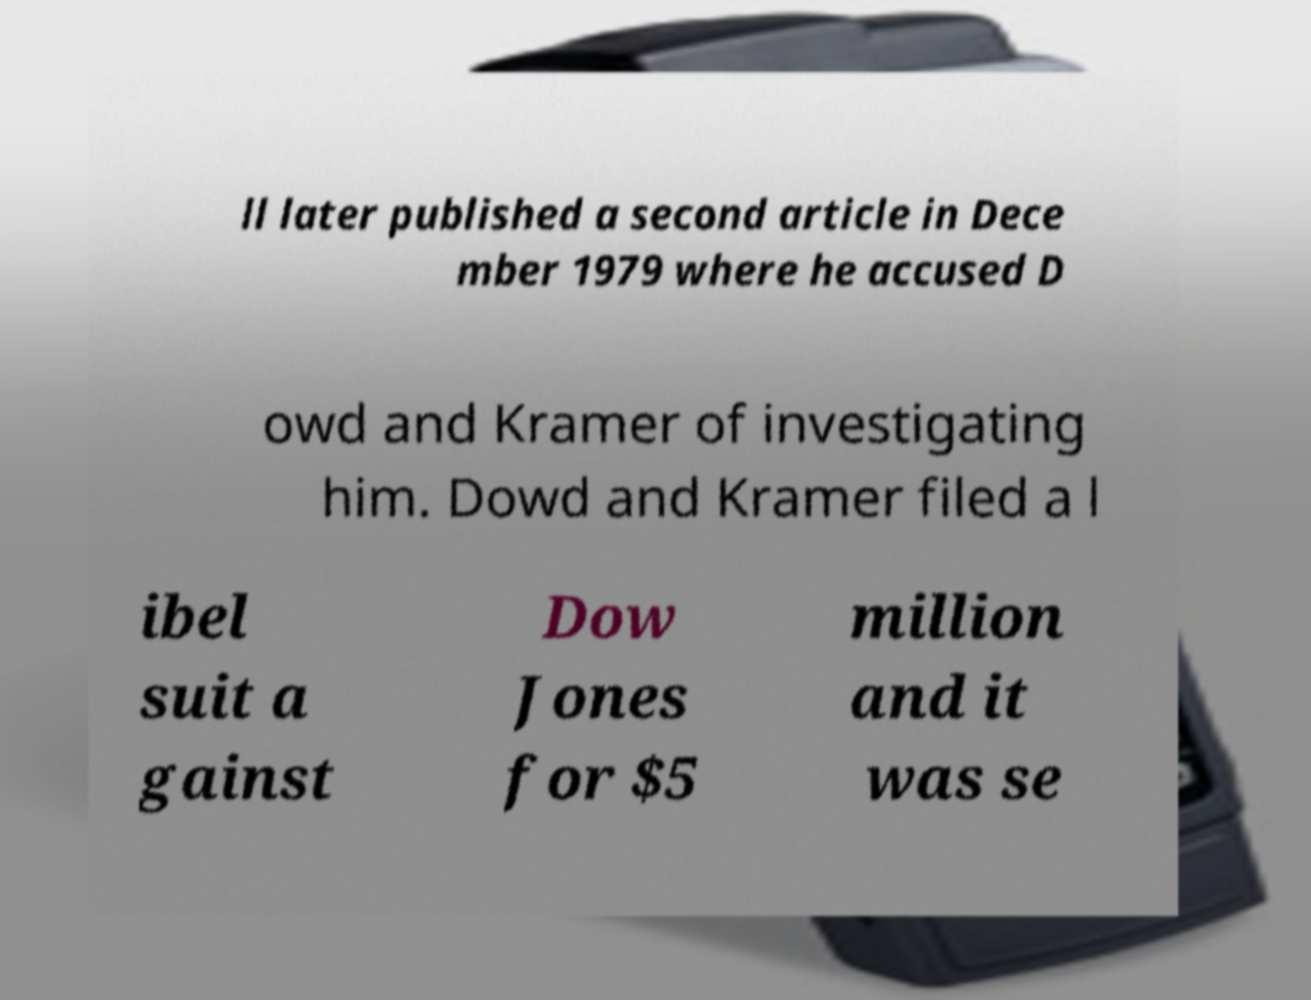Please read and relay the text visible in this image. What does it say? ll later published a second article in Dece mber 1979 where he accused D owd and Kramer of investigating him. Dowd and Kramer filed a l ibel suit a gainst Dow Jones for $5 million and it was se 